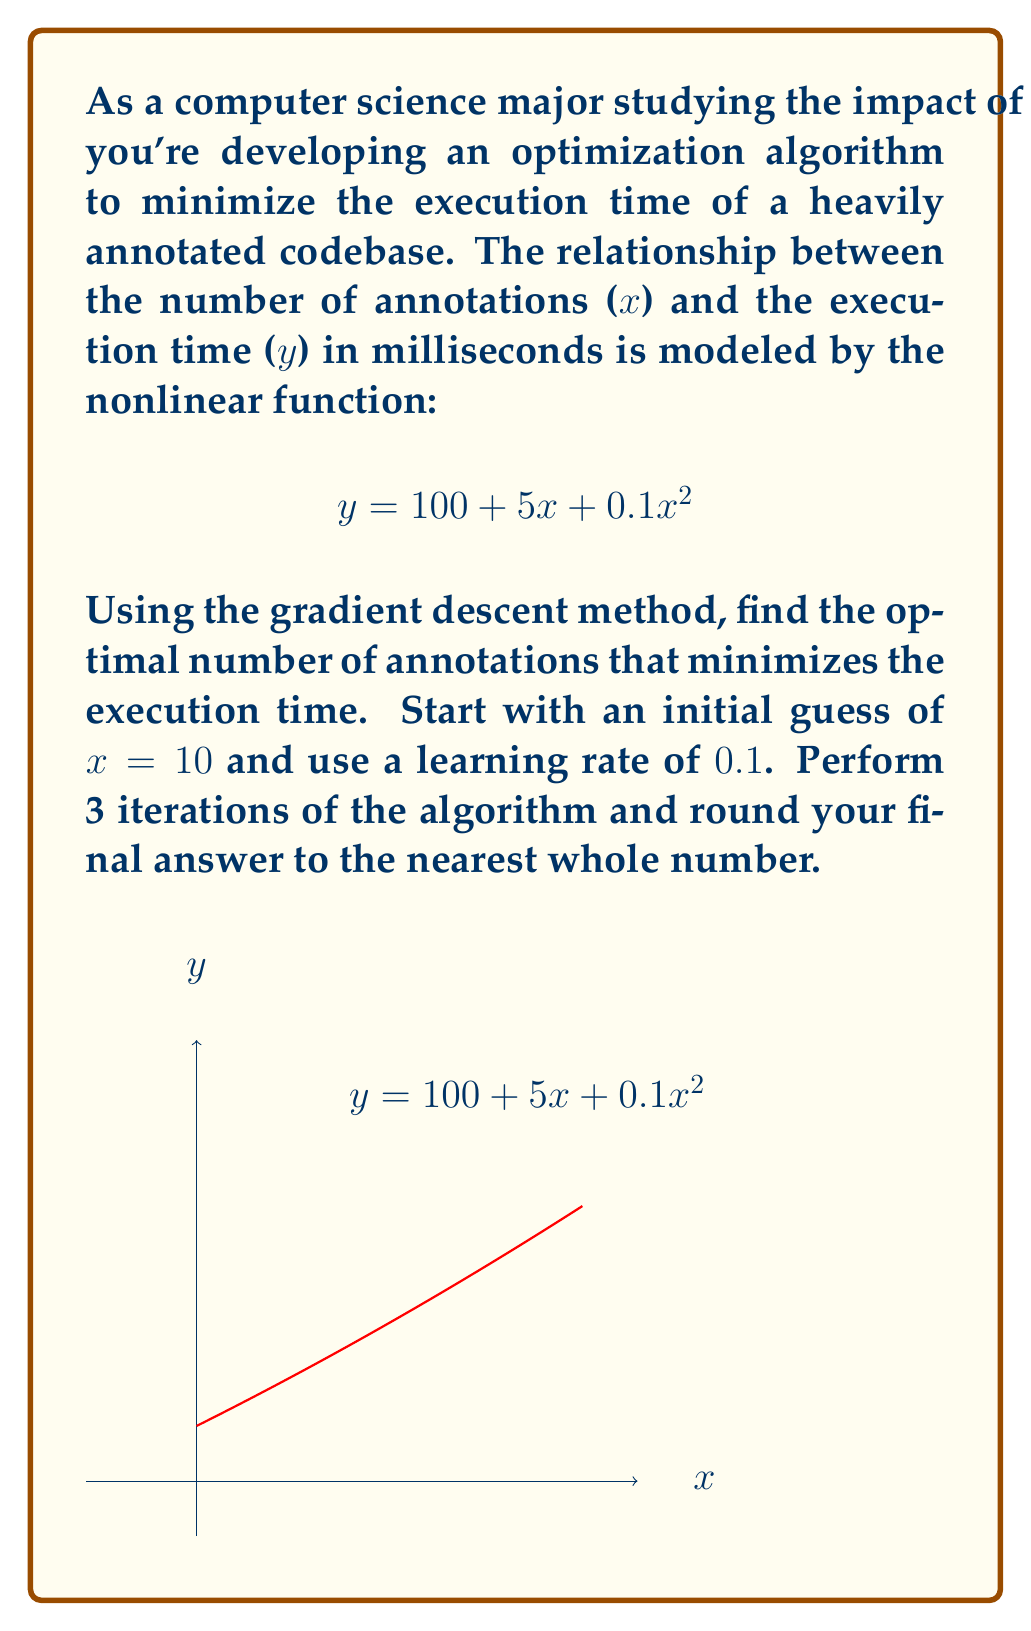Teach me how to tackle this problem. Let's solve this problem step-by-step using the gradient descent method:

1) The objective function is $f(x) = 100 + 5x + 0.1x^2$

2) The derivative of f(x) is $f'(x) = 5 + 0.2x$

3) The gradient descent update rule is:
   $x_{new} = x_{old} - \text{learning_rate} * f'(x_{old})$

4) Starting with x = 10 and learning rate = 0.1, let's perform 3 iterations:

   Iteration 1:
   $f'(10) = 5 + 0.2(10) = 7$
   $x_{new} = 10 - 0.1 * 7 = 9.3$

   Iteration 2:
   $f'(9.3) = 5 + 0.2(9.3) = 6.86$
   $x_{new} = 9.3 - 0.1 * 6.86 = 8.614$

   Iteration 3:
   $f'(8.614) = 5 + 0.2(8.614) = 6.7228$
   $x_{new} = 8.614 - 0.1 * 6.7228 = 7.9412$

5) Rounding the final result to the nearest whole number:
   7.9412 ≈ 8

Therefore, after 3 iterations of gradient descent, the optimal number of annotations that minimizes the execution time is approximately 8.
Answer: 8 